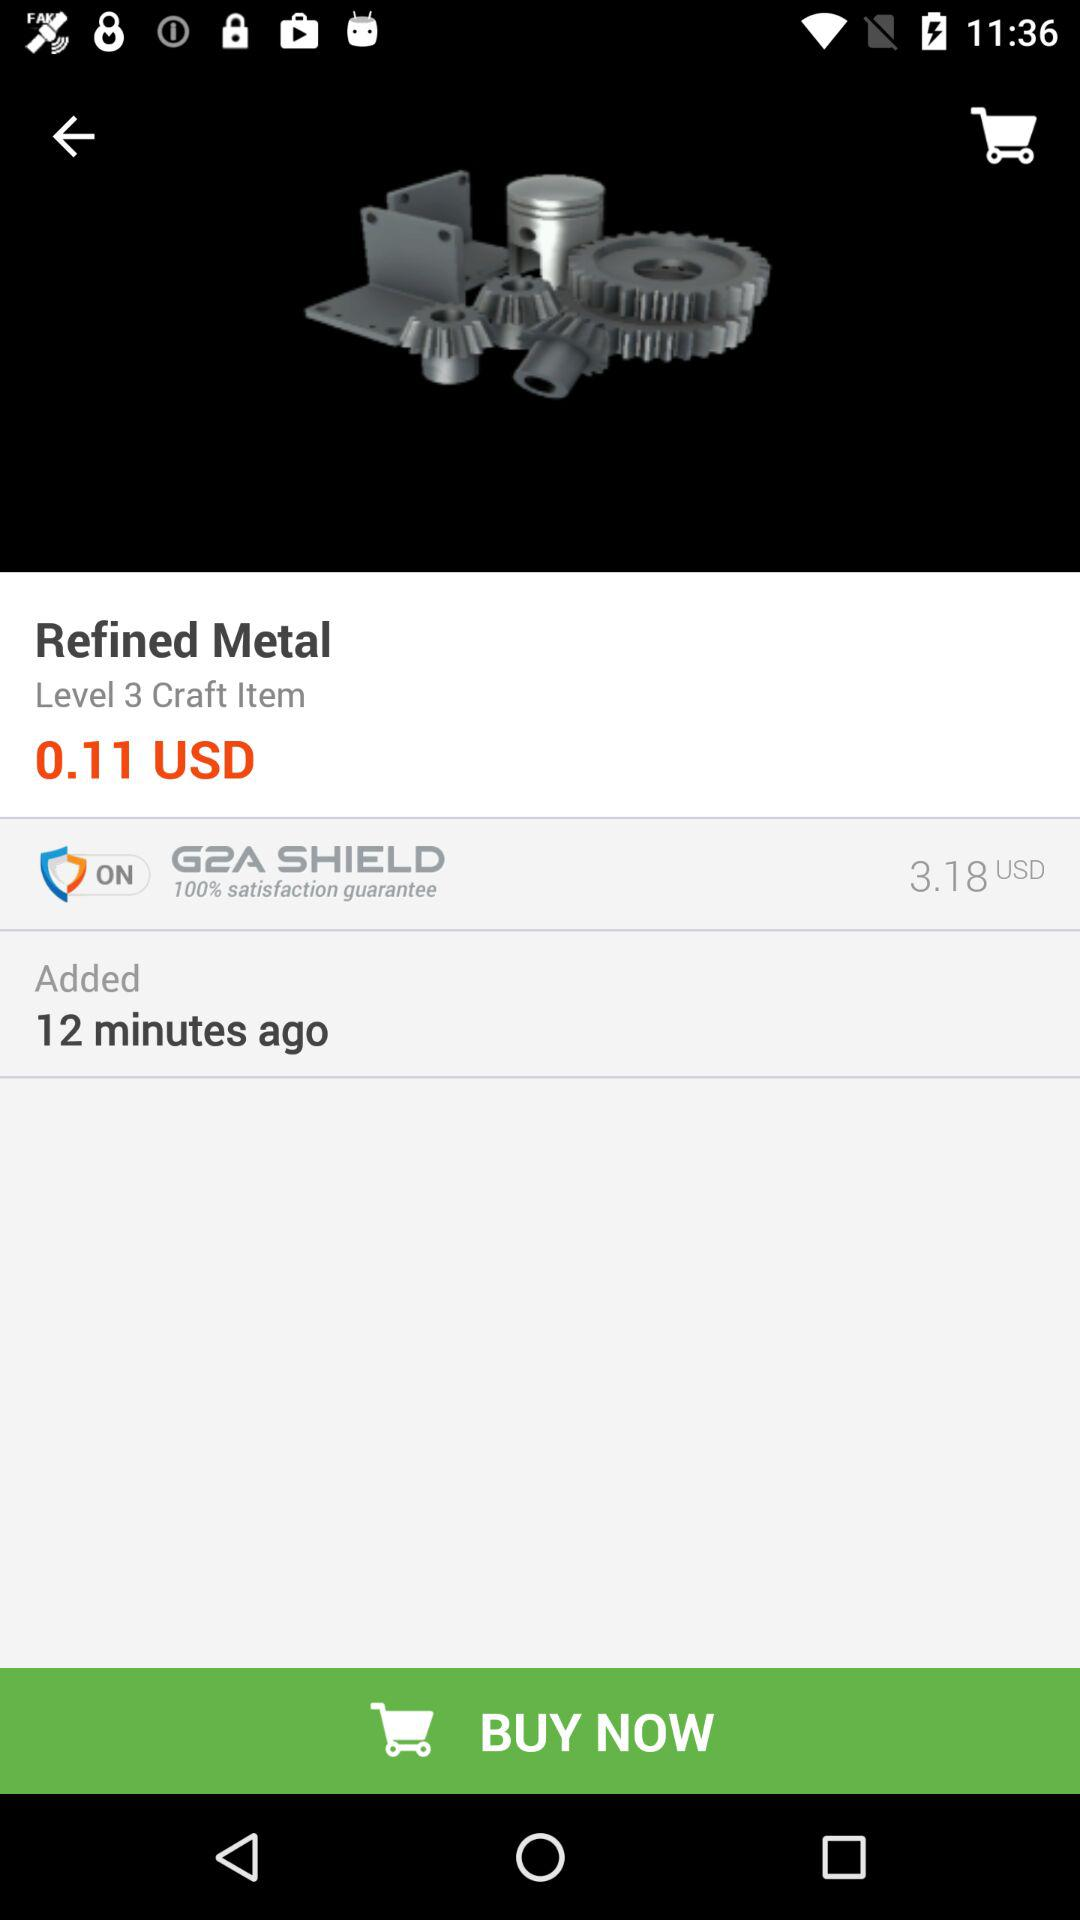What is the level of craft item? The level is 3. 